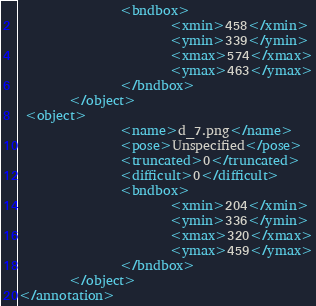<code> <loc_0><loc_0><loc_500><loc_500><_XML_>                <bndbox>
                        <xmin>458</xmin>
                        <ymin>339</ymin>
                        <xmax>574</xmax>
                        <ymax>463</ymax>
                </bndbox>
        </object>
 <object>
                <name>d_7.png</name>
                <pose>Unspecified</pose>
                <truncated>0</truncated>
                <difficult>0</difficult>
                <bndbox>
                        <xmin>204</xmin>
                        <ymin>336</ymin>
                        <xmax>320</xmax>
                        <ymax>459</ymax>
                </bndbox>
        </object>
</annotation>        
</code> 